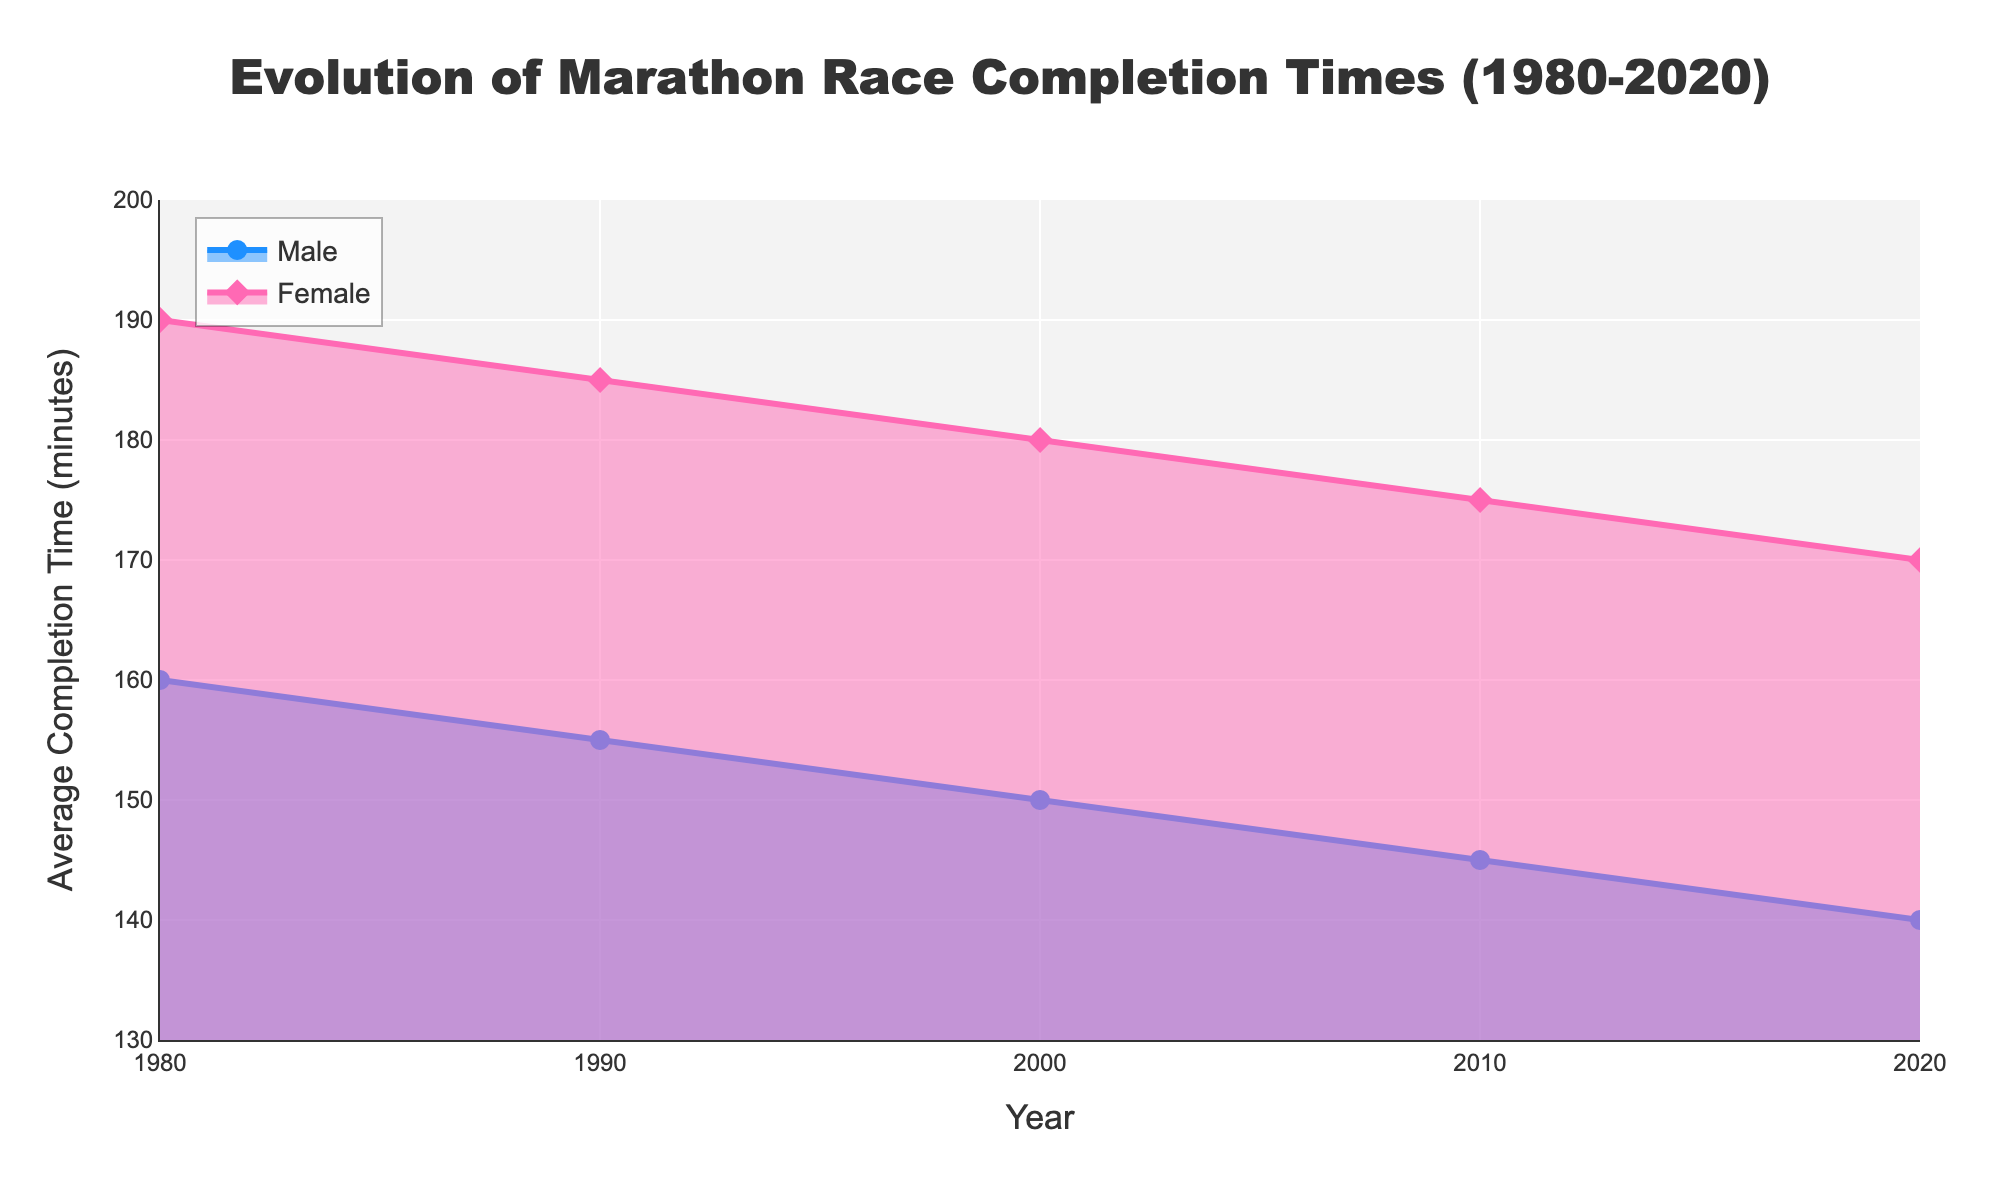What is the title of the figure? The title is prominently displayed at the top of the figure.
Answer: Evolution of Marathon Race Completion Times (1980-2020) How many data points are there for each gender? Each decade from 1980 to 2020 is marked, providing one data point per gender per decade.
Answer: 5 Which gender had a higher average completion time in 2000? Look at the values for the year 2000 and compare them for males and females.
Answer: Female How has the average completion time for males changed from 1980 to 2020? Compare the average completion time values for males in 1980 and 2020 to see the change.
Answer: Decreased What year shows the smallest gap between male and female average completion times? Calculate the difference between male and female times for each year and determine the smallest gap.
Answer: 2020 Which year had the highest average completion time for females? Identify the highest value on the female line on the y-axis.
Answer: 1980 What is the average completion time for males in 2020? Look at the value for males in the year 2020 on the y-axis.
Answer: 140 minutes What is the overall trend for average completion times for both genders from 1980 to 2020? Examine the direction of the lines over time for both genders.
Answer: Decreasing By how many minutes did the female average completion time decrease from 1980 to 2020? Subtract the female completion time in 2020 from the time in 1980.
Answer: 20 minutes In what year did the average completion time for males first drop below 150 minutes? Locate the first point on the male line where the value is below 150 minutes.
Answer: 2000 